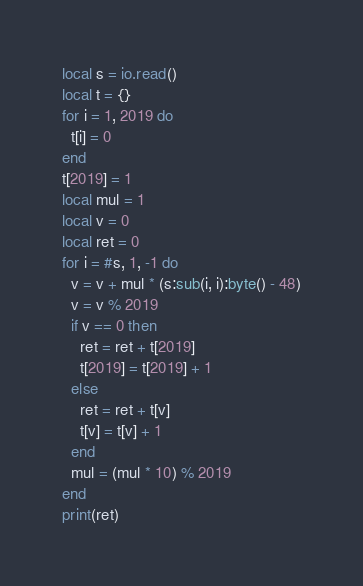<code> <loc_0><loc_0><loc_500><loc_500><_Lua_>local s = io.read()
local t = {}
for i = 1, 2019 do
  t[i] = 0
end
t[2019] = 1
local mul = 1
local v = 0
local ret = 0
for i = #s, 1, -1 do
  v = v + mul * (s:sub(i, i):byte() - 48)
  v = v % 2019
  if v == 0 then
    ret = ret + t[2019]
    t[2019] = t[2019] + 1
  else
    ret = ret + t[v]
    t[v] = t[v] + 1
  end
  mul = (mul * 10) % 2019
end
print(ret)
</code> 